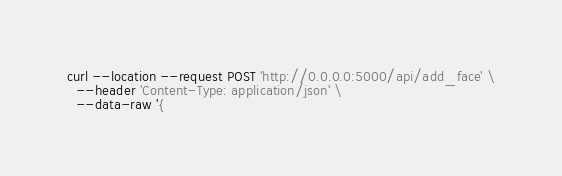<code> <loc_0><loc_0><loc_500><loc_500><_Bash_>curl --location --request POST 'http://0.0.0.0:5000/api/add_face' \
  --header 'Content-Type: application/json' \
  --data-raw '{</code> 